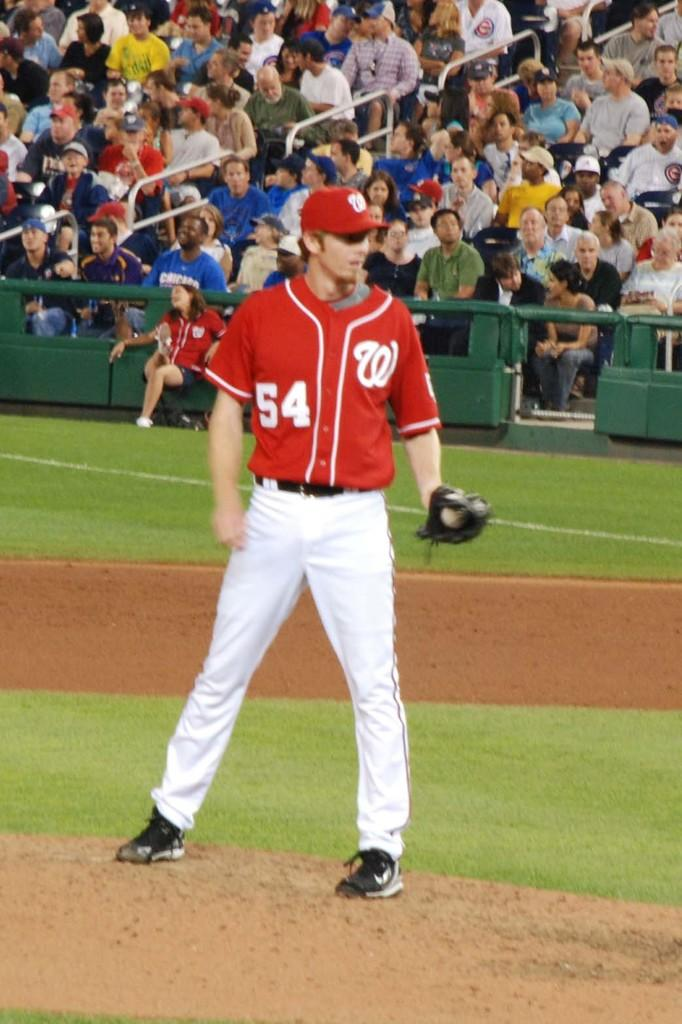Provide a one-sentence caption for the provided image. a pitcher that has the letter W on their jersey. 